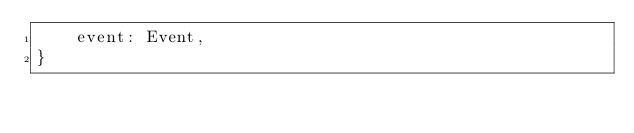Convert code to text. <code><loc_0><loc_0><loc_500><loc_500><_Rust_>    event: Event,
}
</code> 